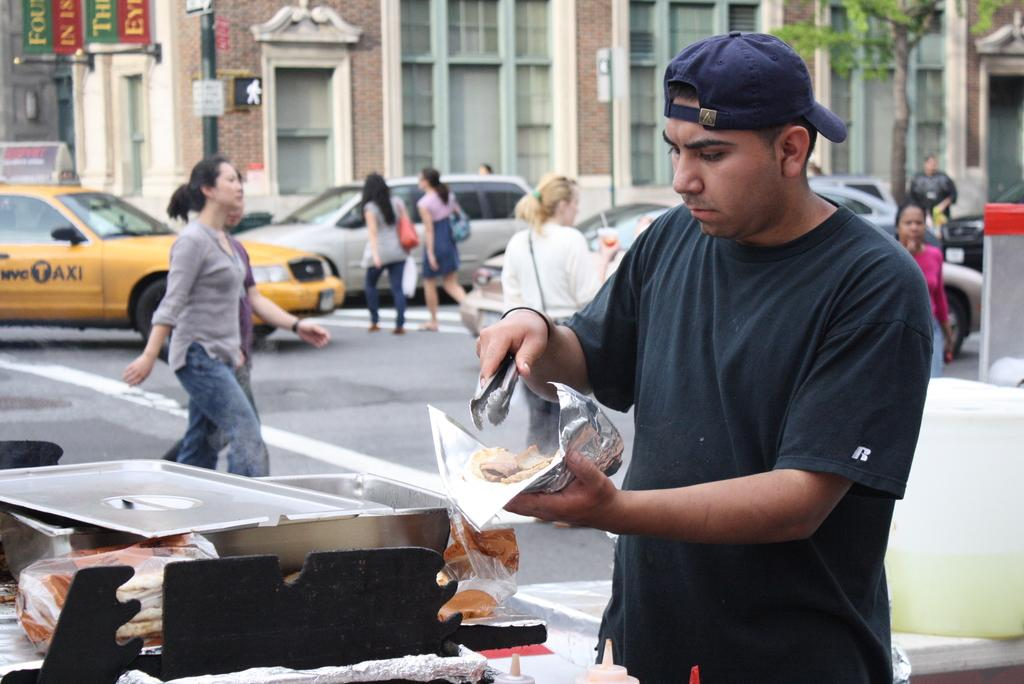Provide a one-sentence caption for the provided image. A man with an R on his t shirt is getting food on the roadside. 